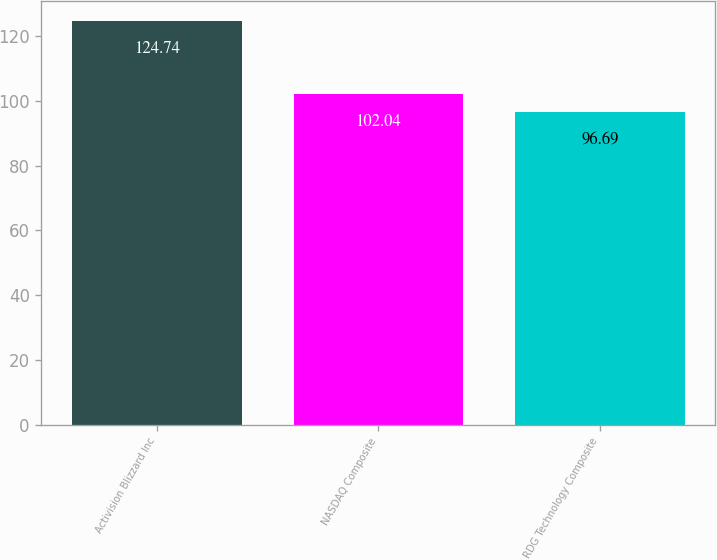<chart> <loc_0><loc_0><loc_500><loc_500><bar_chart><fcel>Activision Blizzard Inc<fcel>NASDAQ Composite<fcel>RDG Technology Composite<nl><fcel>124.74<fcel>102.04<fcel>96.69<nl></chart> 